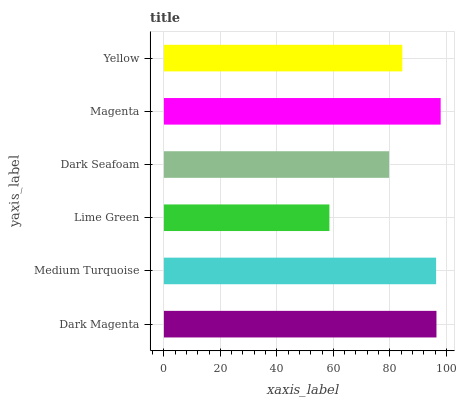Is Lime Green the minimum?
Answer yes or no. Yes. Is Magenta the maximum?
Answer yes or no. Yes. Is Medium Turquoise the minimum?
Answer yes or no. No. Is Medium Turquoise the maximum?
Answer yes or no. No. Is Dark Magenta greater than Medium Turquoise?
Answer yes or no. Yes. Is Medium Turquoise less than Dark Magenta?
Answer yes or no. Yes. Is Medium Turquoise greater than Dark Magenta?
Answer yes or no. No. Is Dark Magenta less than Medium Turquoise?
Answer yes or no. No. Is Medium Turquoise the high median?
Answer yes or no. Yes. Is Yellow the low median?
Answer yes or no. Yes. Is Dark Magenta the high median?
Answer yes or no. No. Is Magenta the low median?
Answer yes or no. No. 